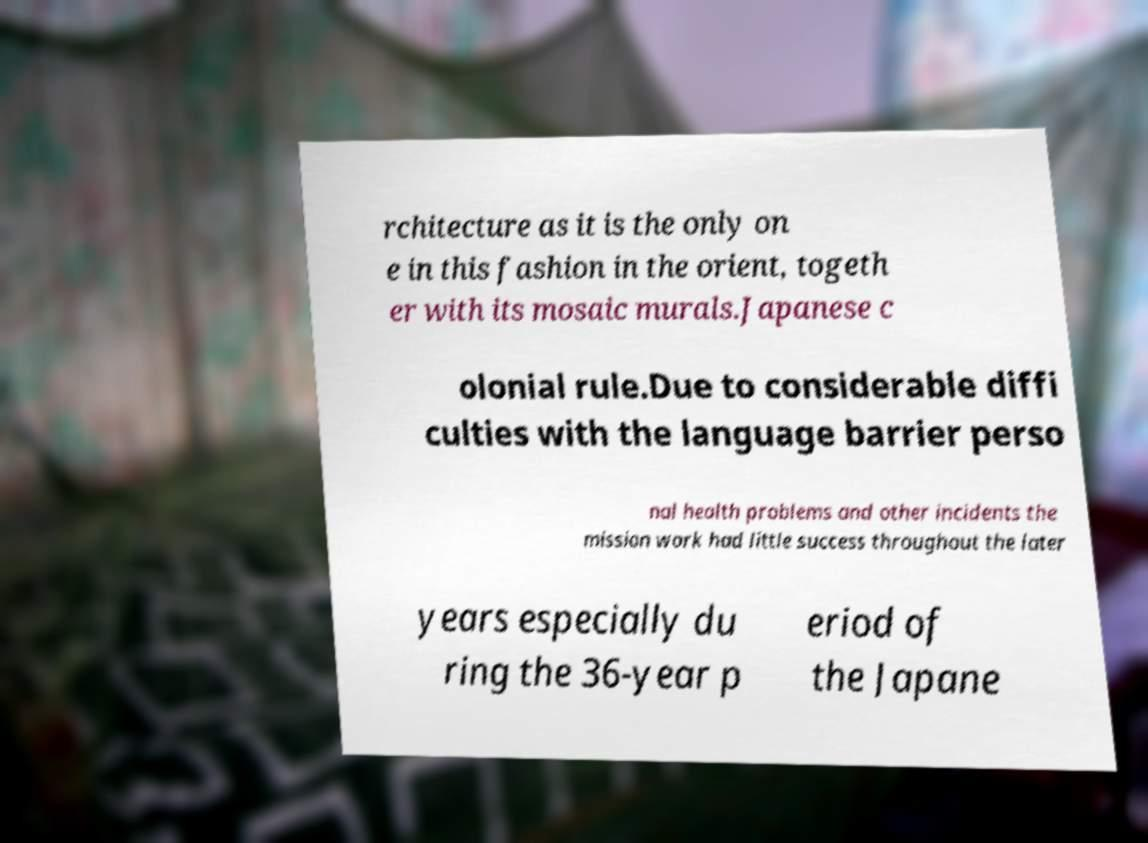Could you extract and type out the text from this image? rchitecture as it is the only on e in this fashion in the orient, togeth er with its mosaic murals.Japanese c olonial rule.Due to considerable diffi culties with the language barrier perso nal health problems and other incidents the mission work had little success throughout the later years especially du ring the 36-year p eriod of the Japane 